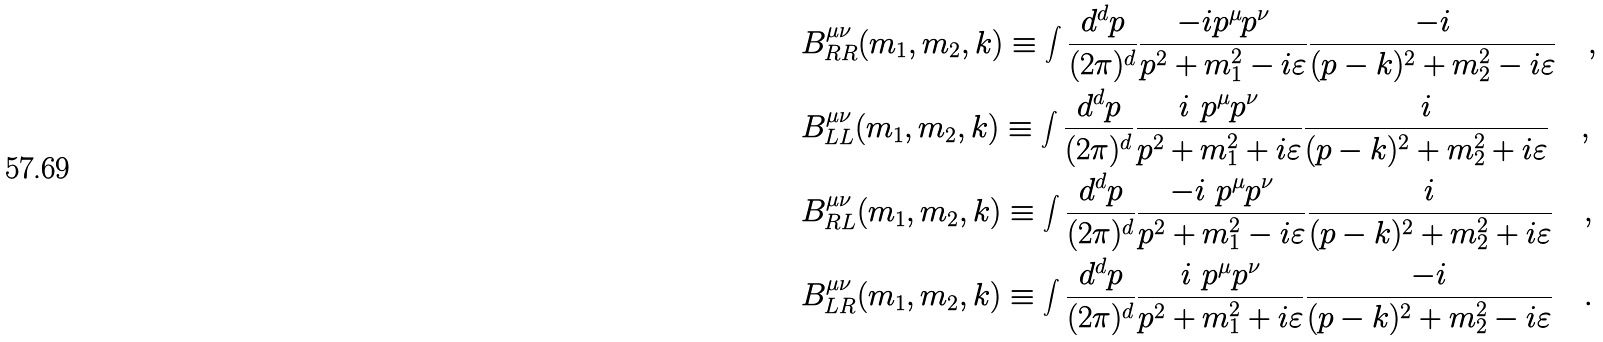<formula> <loc_0><loc_0><loc_500><loc_500>& B ^ { \mu \nu } _ { R R } ( m _ { 1 } , m _ { 2 } , k ) \equiv \int \frac { d ^ { d } p } { ( 2 \pi ) ^ { d } } \frac { - i p ^ { \mu } p ^ { \nu } } { p ^ { 2 } + m _ { 1 } ^ { 2 } - i \varepsilon } \frac { - i } { ( p - k ) ^ { 2 } + m _ { 2 } ^ { 2 } - i \varepsilon } \quad , \\ & B ^ { \mu \nu } _ { L L } ( m _ { 1 } , m _ { 2 } , k ) \equiv \int \frac { d ^ { d } p } { ( 2 \pi ) ^ { d } } \frac { i \ p ^ { \mu } p ^ { \nu } } { p ^ { 2 } + m _ { 1 } ^ { 2 } + i \varepsilon } \frac { i } { ( p - k ) ^ { 2 } + m _ { 2 } ^ { 2 } + i \varepsilon } \quad , \\ & B ^ { \mu \nu } _ { R L } ( m _ { 1 } , m _ { 2 } , k ) \equiv \int \frac { d ^ { d } p } { ( 2 \pi ) ^ { d } } \frac { - i \ p ^ { \mu } p ^ { \nu } } { p ^ { 2 } + m _ { 1 } ^ { 2 } - i \varepsilon } \frac { i } { ( p - k ) ^ { 2 } + m _ { 2 } ^ { 2 } + i \varepsilon } \quad , \\ & B ^ { \mu \nu } _ { L R } ( m _ { 1 } , m _ { 2 } , k ) \equiv \int \frac { d ^ { d } p } { ( 2 \pi ) ^ { d } } \frac { i \ p ^ { \mu } p ^ { \nu } } { p ^ { 2 } + m _ { 1 } ^ { 2 } + i \varepsilon } \frac { - i } { ( p - k ) ^ { 2 } + m _ { 2 } ^ { 2 } - i \varepsilon } \quad . \\</formula> 